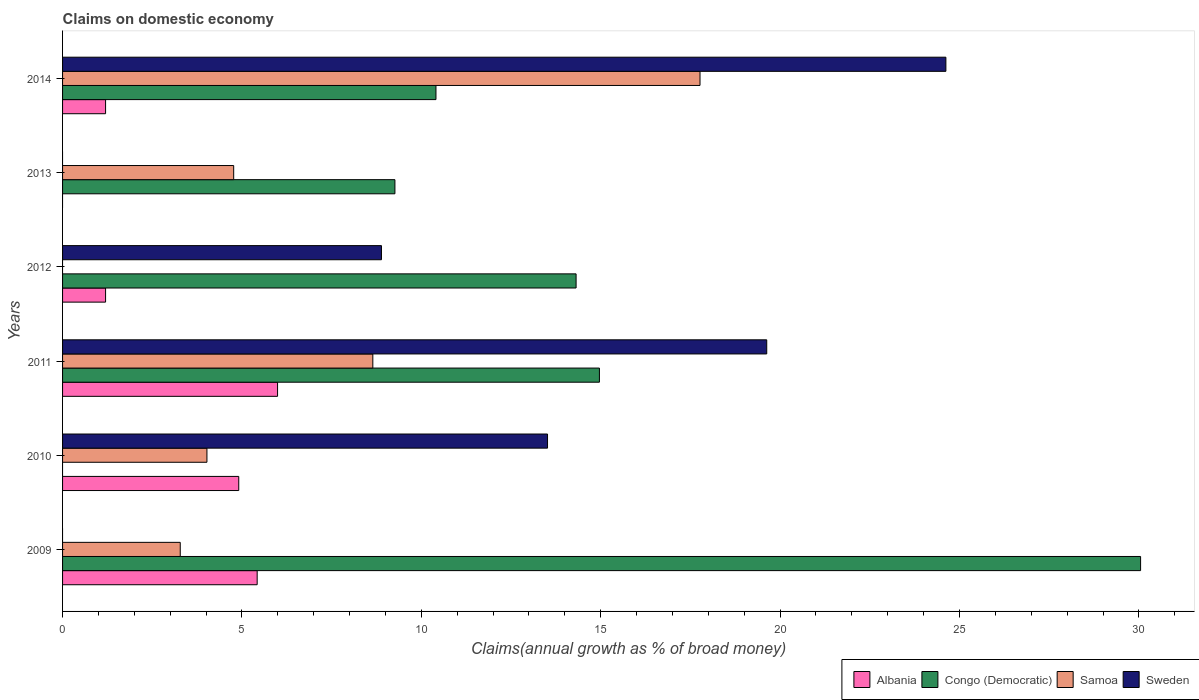How many different coloured bars are there?
Ensure brevity in your answer.  4. Are the number of bars on each tick of the Y-axis equal?
Provide a succinct answer. No. How many bars are there on the 3rd tick from the top?
Your response must be concise. 3. How many bars are there on the 3rd tick from the bottom?
Your response must be concise. 4. In how many cases, is the number of bars for a given year not equal to the number of legend labels?
Give a very brief answer. 4. What is the percentage of broad money claimed on domestic economy in Congo (Democratic) in 2010?
Your answer should be very brief. 0. Across all years, what is the maximum percentage of broad money claimed on domestic economy in Congo (Democratic)?
Your response must be concise. 30.05. Across all years, what is the minimum percentage of broad money claimed on domestic economy in Albania?
Your answer should be compact. 0. In which year was the percentage of broad money claimed on domestic economy in Sweden maximum?
Your answer should be very brief. 2014. What is the total percentage of broad money claimed on domestic economy in Congo (Democratic) in the graph?
Offer a very short reply. 79. What is the difference between the percentage of broad money claimed on domestic economy in Congo (Democratic) in 2009 and that in 2011?
Keep it short and to the point. 15.08. What is the difference between the percentage of broad money claimed on domestic economy in Sweden in 2010 and the percentage of broad money claimed on domestic economy in Albania in 2014?
Offer a terse response. 12.32. What is the average percentage of broad money claimed on domestic economy in Albania per year?
Offer a very short reply. 3.12. In the year 2014, what is the difference between the percentage of broad money claimed on domestic economy in Samoa and percentage of broad money claimed on domestic economy in Albania?
Your response must be concise. 16.57. In how many years, is the percentage of broad money claimed on domestic economy in Congo (Democratic) greater than 12 %?
Provide a succinct answer. 3. What is the ratio of the percentage of broad money claimed on domestic economy in Congo (Democratic) in 2009 to that in 2012?
Provide a succinct answer. 2.1. What is the difference between the highest and the second highest percentage of broad money claimed on domestic economy in Congo (Democratic)?
Provide a succinct answer. 15.08. What is the difference between the highest and the lowest percentage of broad money claimed on domestic economy in Albania?
Your response must be concise. 5.99. In how many years, is the percentage of broad money claimed on domestic economy in Albania greater than the average percentage of broad money claimed on domestic economy in Albania taken over all years?
Give a very brief answer. 3. Is it the case that in every year, the sum of the percentage of broad money claimed on domestic economy in Albania and percentage of broad money claimed on domestic economy in Samoa is greater than the sum of percentage of broad money claimed on domestic economy in Sweden and percentage of broad money claimed on domestic economy in Congo (Democratic)?
Give a very brief answer. No. Is it the case that in every year, the sum of the percentage of broad money claimed on domestic economy in Congo (Democratic) and percentage of broad money claimed on domestic economy in Albania is greater than the percentage of broad money claimed on domestic economy in Sweden?
Your response must be concise. No. Are all the bars in the graph horizontal?
Provide a short and direct response. Yes. How many years are there in the graph?
Offer a very short reply. 6. Does the graph contain grids?
Your answer should be very brief. No. How many legend labels are there?
Keep it short and to the point. 4. How are the legend labels stacked?
Your answer should be compact. Horizontal. What is the title of the graph?
Your response must be concise. Claims on domestic economy. What is the label or title of the X-axis?
Offer a terse response. Claims(annual growth as % of broad money). What is the label or title of the Y-axis?
Your response must be concise. Years. What is the Claims(annual growth as % of broad money) of Albania in 2009?
Provide a short and direct response. 5.42. What is the Claims(annual growth as % of broad money) in Congo (Democratic) in 2009?
Your answer should be compact. 30.05. What is the Claims(annual growth as % of broad money) of Samoa in 2009?
Keep it short and to the point. 3.28. What is the Claims(annual growth as % of broad money) of Sweden in 2009?
Make the answer very short. 0. What is the Claims(annual growth as % of broad money) of Albania in 2010?
Give a very brief answer. 4.91. What is the Claims(annual growth as % of broad money) of Congo (Democratic) in 2010?
Offer a terse response. 0. What is the Claims(annual growth as % of broad money) of Samoa in 2010?
Provide a short and direct response. 4.02. What is the Claims(annual growth as % of broad money) of Sweden in 2010?
Your answer should be compact. 13.52. What is the Claims(annual growth as % of broad money) of Albania in 2011?
Give a very brief answer. 5.99. What is the Claims(annual growth as % of broad money) of Congo (Democratic) in 2011?
Offer a very short reply. 14.96. What is the Claims(annual growth as % of broad money) in Samoa in 2011?
Provide a short and direct response. 8.65. What is the Claims(annual growth as % of broad money) in Sweden in 2011?
Keep it short and to the point. 19.63. What is the Claims(annual growth as % of broad money) in Albania in 2012?
Give a very brief answer. 1.2. What is the Claims(annual growth as % of broad money) of Congo (Democratic) in 2012?
Your response must be concise. 14.31. What is the Claims(annual growth as % of broad money) in Samoa in 2012?
Offer a terse response. 0. What is the Claims(annual growth as % of broad money) in Sweden in 2012?
Keep it short and to the point. 8.89. What is the Claims(annual growth as % of broad money) of Congo (Democratic) in 2013?
Provide a short and direct response. 9.26. What is the Claims(annual growth as % of broad money) of Samoa in 2013?
Your response must be concise. 4.77. What is the Claims(annual growth as % of broad money) of Sweden in 2013?
Your answer should be very brief. 0. What is the Claims(annual growth as % of broad money) in Albania in 2014?
Give a very brief answer. 1.2. What is the Claims(annual growth as % of broad money) of Congo (Democratic) in 2014?
Provide a succinct answer. 10.41. What is the Claims(annual growth as % of broad money) in Samoa in 2014?
Provide a short and direct response. 17.77. What is the Claims(annual growth as % of broad money) of Sweden in 2014?
Provide a succinct answer. 24.62. Across all years, what is the maximum Claims(annual growth as % of broad money) of Albania?
Give a very brief answer. 5.99. Across all years, what is the maximum Claims(annual growth as % of broad money) of Congo (Democratic)?
Ensure brevity in your answer.  30.05. Across all years, what is the maximum Claims(annual growth as % of broad money) in Samoa?
Your response must be concise. 17.77. Across all years, what is the maximum Claims(annual growth as % of broad money) in Sweden?
Your answer should be very brief. 24.62. Across all years, what is the minimum Claims(annual growth as % of broad money) in Congo (Democratic)?
Provide a short and direct response. 0. Across all years, what is the minimum Claims(annual growth as % of broad money) in Samoa?
Your answer should be compact. 0. Across all years, what is the minimum Claims(annual growth as % of broad money) of Sweden?
Ensure brevity in your answer.  0. What is the total Claims(annual growth as % of broad money) in Albania in the graph?
Provide a succinct answer. 18.73. What is the total Claims(annual growth as % of broad money) of Congo (Democratic) in the graph?
Offer a very short reply. 79. What is the total Claims(annual growth as % of broad money) in Samoa in the graph?
Make the answer very short. 38.49. What is the total Claims(annual growth as % of broad money) of Sweden in the graph?
Your answer should be compact. 66.65. What is the difference between the Claims(annual growth as % of broad money) in Albania in 2009 and that in 2010?
Make the answer very short. 0.51. What is the difference between the Claims(annual growth as % of broad money) of Samoa in 2009 and that in 2010?
Your response must be concise. -0.74. What is the difference between the Claims(annual growth as % of broad money) of Albania in 2009 and that in 2011?
Ensure brevity in your answer.  -0.57. What is the difference between the Claims(annual growth as % of broad money) of Congo (Democratic) in 2009 and that in 2011?
Keep it short and to the point. 15.08. What is the difference between the Claims(annual growth as % of broad money) of Samoa in 2009 and that in 2011?
Your answer should be compact. -5.37. What is the difference between the Claims(annual growth as % of broad money) in Albania in 2009 and that in 2012?
Your response must be concise. 4.23. What is the difference between the Claims(annual growth as % of broad money) in Congo (Democratic) in 2009 and that in 2012?
Keep it short and to the point. 15.73. What is the difference between the Claims(annual growth as % of broad money) in Congo (Democratic) in 2009 and that in 2013?
Offer a very short reply. 20.78. What is the difference between the Claims(annual growth as % of broad money) in Samoa in 2009 and that in 2013?
Provide a succinct answer. -1.49. What is the difference between the Claims(annual growth as % of broad money) of Albania in 2009 and that in 2014?
Your answer should be very brief. 4.23. What is the difference between the Claims(annual growth as % of broad money) in Congo (Democratic) in 2009 and that in 2014?
Your answer should be compact. 19.64. What is the difference between the Claims(annual growth as % of broad money) in Samoa in 2009 and that in 2014?
Your answer should be compact. -14.49. What is the difference between the Claims(annual growth as % of broad money) of Albania in 2010 and that in 2011?
Your response must be concise. -1.08. What is the difference between the Claims(annual growth as % of broad money) in Samoa in 2010 and that in 2011?
Provide a short and direct response. -4.62. What is the difference between the Claims(annual growth as % of broad money) of Sweden in 2010 and that in 2011?
Ensure brevity in your answer.  -6.11. What is the difference between the Claims(annual growth as % of broad money) in Albania in 2010 and that in 2012?
Provide a succinct answer. 3.71. What is the difference between the Claims(annual growth as % of broad money) of Sweden in 2010 and that in 2012?
Provide a short and direct response. 4.63. What is the difference between the Claims(annual growth as % of broad money) of Samoa in 2010 and that in 2013?
Keep it short and to the point. -0.75. What is the difference between the Claims(annual growth as % of broad money) in Albania in 2010 and that in 2014?
Your response must be concise. 3.71. What is the difference between the Claims(annual growth as % of broad money) of Samoa in 2010 and that in 2014?
Offer a terse response. -13.74. What is the difference between the Claims(annual growth as % of broad money) of Sweden in 2010 and that in 2014?
Give a very brief answer. -11.1. What is the difference between the Claims(annual growth as % of broad money) in Albania in 2011 and that in 2012?
Offer a very short reply. 4.79. What is the difference between the Claims(annual growth as % of broad money) of Congo (Democratic) in 2011 and that in 2012?
Make the answer very short. 0.65. What is the difference between the Claims(annual growth as % of broad money) in Sweden in 2011 and that in 2012?
Give a very brief answer. 10.74. What is the difference between the Claims(annual growth as % of broad money) in Congo (Democratic) in 2011 and that in 2013?
Provide a short and direct response. 5.7. What is the difference between the Claims(annual growth as % of broad money) in Samoa in 2011 and that in 2013?
Ensure brevity in your answer.  3.88. What is the difference between the Claims(annual growth as % of broad money) in Albania in 2011 and that in 2014?
Provide a succinct answer. 4.79. What is the difference between the Claims(annual growth as % of broad money) of Congo (Democratic) in 2011 and that in 2014?
Your response must be concise. 4.56. What is the difference between the Claims(annual growth as % of broad money) in Samoa in 2011 and that in 2014?
Your answer should be very brief. -9.12. What is the difference between the Claims(annual growth as % of broad money) in Sweden in 2011 and that in 2014?
Give a very brief answer. -4.99. What is the difference between the Claims(annual growth as % of broad money) in Congo (Democratic) in 2012 and that in 2013?
Keep it short and to the point. 5.05. What is the difference between the Claims(annual growth as % of broad money) of Albania in 2012 and that in 2014?
Give a very brief answer. -0. What is the difference between the Claims(annual growth as % of broad money) of Congo (Democratic) in 2012 and that in 2014?
Offer a terse response. 3.91. What is the difference between the Claims(annual growth as % of broad money) of Sweden in 2012 and that in 2014?
Make the answer very short. -15.73. What is the difference between the Claims(annual growth as % of broad money) of Congo (Democratic) in 2013 and that in 2014?
Your answer should be compact. -1.14. What is the difference between the Claims(annual growth as % of broad money) of Samoa in 2013 and that in 2014?
Keep it short and to the point. -13. What is the difference between the Claims(annual growth as % of broad money) of Albania in 2009 and the Claims(annual growth as % of broad money) of Samoa in 2010?
Offer a very short reply. 1.4. What is the difference between the Claims(annual growth as % of broad money) of Albania in 2009 and the Claims(annual growth as % of broad money) of Sweden in 2010?
Provide a short and direct response. -8.09. What is the difference between the Claims(annual growth as % of broad money) in Congo (Democratic) in 2009 and the Claims(annual growth as % of broad money) in Samoa in 2010?
Offer a terse response. 26.02. What is the difference between the Claims(annual growth as % of broad money) of Congo (Democratic) in 2009 and the Claims(annual growth as % of broad money) of Sweden in 2010?
Offer a terse response. 16.53. What is the difference between the Claims(annual growth as % of broad money) in Samoa in 2009 and the Claims(annual growth as % of broad money) in Sweden in 2010?
Your response must be concise. -10.24. What is the difference between the Claims(annual growth as % of broad money) in Albania in 2009 and the Claims(annual growth as % of broad money) in Congo (Democratic) in 2011?
Keep it short and to the point. -9.54. What is the difference between the Claims(annual growth as % of broad money) of Albania in 2009 and the Claims(annual growth as % of broad money) of Samoa in 2011?
Give a very brief answer. -3.22. What is the difference between the Claims(annual growth as % of broad money) of Albania in 2009 and the Claims(annual growth as % of broad money) of Sweden in 2011?
Your answer should be compact. -14.2. What is the difference between the Claims(annual growth as % of broad money) of Congo (Democratic) in 2009 and the Claims(annual growth as % of broad money) of Samoa in 2011?
Provide a succinct answer. 21.4. What is the difference between the Claims(annual growth as % of broad money) in Congo (Democratic) in 2009 and the Claims(annual growth as % of broad money) in Sweden in 2011?
Keep it short and to the point. 10.42. What is the difference between the Claims(annual growth as % of broad money) in Samoa in 2009 and the Claims(annual growth as % of broad money) in Sweden in 2011?
Provide a succinct answer. -16.35. What is the difference between the Claims(annual growth as % of broad money) in Albania in 2009 and the Claims(annual growth as % of broad money) in Congo (Democratic) in 2012?
Give a very brief answer. -8.89. What is the difference between the Claims(annual growth as % of broad money) in Albania in 2009 and the Claims(annual growth as % of broad money) in Sweden in 2012?
Keep it short and to the point. -3.46. What is the difference between the Claims(annual growth as % of broad money) in Congo (Democratic) in 2009 and the Claims(annual growth as % of broad money) in Sweden in 2012?
Provide a short and direct response. 21.16. What is the difference between the Claims(annual growth as % of broad money) in Samoa in 2009 and the Claims(annual growth as % of broad money) in Sweden in 2012?
Offer a terse response. -5.61. What is the difference between the Claims(annual growth as % of broad money) in Albania in 2009 and the Claims(annual growth as % of broad money) in Congo (Democratic) in 2013?
Keep it short and to the point. -3.84. What is the difference between the Claims(annual growth as % of broad money) of Albania in 2009 and the Claims(annual growth as % of broad money) of Samoa in 2013?
Your answer should be very brief. 0.65. What is the difference between the Claims(annual growth as % of broad money) in Congo (Democratic) in 2009 and the Claims(annual growth as % of broad money) in Samoa in 2013?
Offer a terse response. 25.28. What is the difference between the Claims(annual growth as % of broad money) of Albania in 2009 and the Claims(annual growth as % of broad money) of Congo (Democratic) in 2014?
Your answer should be compact. -4.98. What is the difference between the Claims(annual growth as % of broad money) of Albania in 2009 and the Claims(annual growth as % of broad money) of Samoa in 2014?
Ensure brevity in your answer.  -12.34. What is the difference between the Claims(annual growth as % of broad money) of Albania in 2009 and the Claims(annual growth as % of broad money) of Sweden in 2014?
Your answer should be compact. -19.2. What is the difference between the Claims(annual growth as % of broad money) in Congo (Democratic) in 2009 and the Claims(annual growth as % of broad money) in Samoa in 2014?
Your response must be concise. 12.28. What is the difference between the Claims(annual growth as % of broad money) of Congo (Democratic) in 2009 and the Claims(annual growth as % of broad money) of Sweden in 2014?
Make the answer very short. 5.43. What is the difference between the Claims(annual growth as % of broad money) of Samoa in 2009 and the Claims(annual growth as % of broad money) of Sweden in 2014?
Your answer should be very brief. -21.34. What is the difference between the Claims(annual growth as % of broad money) of Albania in 2010 and the Claims(annual growth as % of broad money) of Congo (Democratic) in 2011?
Make the answer very short. -10.05. What is the difference between the Claims(annual growth as % of broad money) of Albania in 2010 and the Claims(annual growth as % of broad money) of Samoa in 2011?
Provide a short and direct response. -3.74. What is the difference between the Claims(annual growth as % of broad money) of Albania in 2010 and the Claims(annual growth as % of broad money) of Sweden in 2011?
Your answer should be compact. -14.72. What is the difference between the Claims(annual growth as % of broad money) in Samoa in 2010 and the Claims(annual growth as % of broad money) in Sweden in 2011?
Ensure brevity in your answer.  -15.6. What is the difference between the Claims(annual growth as % of broad money) in Albania in 2010 and the Claims(annual growth as % of broad money) in Congo (Democratic) in 2012?
Provide a short and direct response. -9.4. What is the difference between the Claims(annual growth as % of broad money) of Albania in 2010 and the Claims(annual growth as % of broad money) of Sweden in 2012?
Your response must be concise. -3.98. What is the difference between the Claims(annual growth as % of broad money) in Samoa in 2010 and the Claims(annual growth as % of broad money) in Sweden in 2012?
Keep it short and to the point. -4.86. What is the difference between the Claims(annual growth as % of broad money) in Albania in 2010 and the Claims(annual growth as % of broad money) in Congo (Democratic) in 2013?
Keep it short and to the point. -4.35. What is the difference between the Claims(annual growth as % of broad money) of Albania in 2010 and the Claims(annual growth as % of broad money) of Samoa in 2013?
Provide a short and direct response. 0.14. What is the difference between the Claims(annual growth as % of broad money) in Albania in 2010 and the Claims(annual growth as % of broad money) in Congo (Democratic) in 2014?
Offer a very short reply. -5.5. What is the difference between the Claims(annual growth as % of broad money) of Albania in 2010 and the Claims(annual growth as % of broad money) of Samoa in 2014?
Offer a terse response. -12.86. What is the difference between the Claims(annual growth as % of broad money) of Albania in 2010 and the Claims(annual growth as % of broad money) of Sweden in 2014?
Ensure brevity in your answer.  -19.71. What is the difference between the Claims(annual growth as % of broad money) in Samoa in 2010 and the Claims(annual growth as % of broad money) in Sweden in 2014?
Offer a very short reply. -20.6. What is the difference between the Claims(annual growth as % of broad money) of Albania in 2011 and the Claims(annual growth as % of broad money) of Congo (Democratic) in 2012?
Give a very brief answer. -8.32. What is the difference between the Claims(annual growth as % of broad money) in Albania in 2011 and the Claims(annual growth as % of broad money) in Sweden in 2012?
Your answer should be very brief. -2.9. What is the difference between the Claims(annual growth as % of broad money) in Congo (Democratic) in 2011 and the Claims(annual growth as % of broad money) in Sweden in 2012?
Keep it short and to the point. 6.08. What is the difference between the Claims(annual growth as % of broad money) in Samoa in 2011 and the Claims(annual growth as % of broad money) in Sweden in 2012?
Provide a short and direct response. -0.24. What is the difference between the Claims(annual growth as % of broad money) in Albania in 2011 and the Claims(annual growth as % of broad money) in Congo (Democratic) in 2013?
Your response must be concise. -3.27. What is the difference between the Claims(annual growth as % of broad money) in Albania in 2011 and the Claims(annual growth as % of broad money) in Samoa in 2013?
Provide a succinct answer. 1.22. What is the difference between the Claims(annual growth as % of broad money) of Congo (Democratic) in 2011 and the Claims(annual growth as % of broad money) of Samoa in 2013?
Provide a succinct answer. 10.19. What is the difference between the Claims(annual growth as % of broad money) of Albania in 2011 and the Claims(annual growth as % of broad money) of Congo (Democratic) in 2014?
Offer a very short reply. -4.42. What is the difference between the Claims(annual growth as % of broad money) in Albania in 2011 and the Claims(annual growth as % of broad money) in Samoa in 2014?
Your answer should be compact. -11.78. What is the difference between the Claims(annual growth as % of broad money) of Albania in 2011 and the Claims(annual growth as % of broad money) of Sweden in 2014?
Give a very brief answer. -18.63. What is the difference between the Claims(annual growth as % of broad money) of Congo (Democratic) in 2011 and the Claims(annual growth as % of broad money) of Samoa in 2014?
Your response must be concise. -2.8. What is the difference between the Claims(annual growth as % of broad money) of Congo (Democratic) in 2011 and the Claims(annual growth as % of broad money) of Sweden in 2014?
Make the answer very short. -9.66. What is the difference between the Claims(annual growth as % of broad money) of Samoa in 2011 and the Claims(annual growth as % of broad money) of Sweden in 2014?
Offer a very short reply. -15.97. What is the difference between the Claims(annual growth as % of broad money) in Albania in 2012 and the Claims(annual growth as % of broad money) in Congo (Democratic) in 2013?
Your answer should be very brief. -8.07. What is the difference between the Claims(annual growth as % of broad money) in Albania in 2012 and the Claims(annual growth as % of broad money) in Samoa in 2013?
Ensure brevity in your answer.  -3.57. What is the difference between the Claims(annual growth as % of broad money) of Congo (Democratic) in 2012 and the Claims(annual growth as % of broad money) of Samoa in 2013?
Your response must be concise. 9.54. What is the difference between the Claims(annual growth as % of broad money) of Albania in 2012 and the Claims(annual growth as % of broad money) of Congo (Democratic) in 2014?
Keep it short and to the point. -9.21. What is the difference between the Claims(annual growth as % of broad money) in Albania in 2012 and the Claims(annual growth as % of broad money) in Samoa in 2014?
Your answer should be compact. -16.57. What is the difference between the Claims(annual growth as % of broad money) in Albania in 2012 and the Claims(annual growth as % of broad money) in Sweden in 2014?
Offer a terse response. -23.42. What is the difference between the Claims(annual growth as % of broad money) in Congo (Democratic) in 2012 and the Claims(annual growth as % of broad money) in Samoa in 2014?
Provide a short and direct response. -3.45. What is the difference between the Claims(annual growth as % of broad money) of Congo (Democratic) in 2012 and the Claims(annual growth as % of broad money) of Sweden in 2014?
Provide a short and direct response. -10.31. What is the difference between the Claims(annual growth as % of broad money) of Congo (Democratic) in 2013 and the Claims(annual growth as % of broad money) of Samoa in 2014?
Keep it short and to the point. -8.5. What is the difference between the Claims(annual growth as % of broad money) of Congo (Democratic) in 2013 and the Claims(annual growth as % of broad money) of Sweden in 2014?
Ensure brevity in your answer.  -15.36. What is the difference between the Claims(annual growth as % of broad money) in Samoa in 2013 and the Claims(annual growth as % of broad money) in Sweden in 2014?
Give a very brief answer. -19.85. What is the average Claims(annual growth as % of broad money) in Albania per year?
Offer a very short reply. 3.12. What is the average Claims(annual growth as % of broad money) of Congo (Democratic) per year?
Your answer should be very brief. 13.17. What is the average Claims(annual growth as % of broad money) of Samoa per year?
Keep it short and to the point. 6.42. What is the average Claims(annual growth as % of broad money) in Sweden per year?
Your answer should be compact. 11.11. In the year 2009, what is the difference between the Claims(annual growth as % of broad money) of Albania and Claims(annual growth as % of broad money) of Congo (Democratic)?
Ensure brevity in your answer.  -24.62. In the year 2009, what is the difference between the Claims(annual growth as % of broad money) of Albania and Claims(annual growth as % of broad money) of Samoa?
Your answer should be very brief. 2.14. In the year 2009, what is the difference between the Claims(annual growth as % of broad money) of Congo (Democratic) and Claims(annual growth as % of broad money) of Samoa?
Give a very brief answer. 26.77. In the year 2010, what is the difference between the Claims(annual growth as % of broad money) in Albania and Claims(annual growth as % of broad money) in Samoa?
Your response must be concise. 0.89. In the year 2010, what is the difference between the Claims(annual growth as % of broad money) of Albania and Claims(annual growth as % of broad money) of Sweden?
Your answer should be compact. -8.61. In the year 2010, what is the difference between the Claims(annual growth as % of broad money) in Samoa and Claims(annual growth as % of broad money) in Sweden?
Offer a terse response. -9.49. In the year 2011, what is the difference between the Claims(annual growth as % of broad money) in Albania and Claims(annual growth as % of broad money) in Congo (Democratic)?
Your answer should be very brief. -8.97. In the year 2011, what is the difference between the Claims(annual growth as % of broad money) in Albania and Claims(annual growth as % of broad money) in Samoa?
Your answer should be very brief. -2.66. In the year 2011, what is the difference between the Claims(annual growth as % of broad money) in Albania and Claims(annual growth as % of broad money) in Sweden?
Ensure brevity in your answer.  -13.63. In the year 2011, what is the difference between the Claims(annual growth as % of broad money) of Congo (Democratic) and Claims(annual growth as % of broad money) of Samoa?
Offer a terse response. 6.32. In the year 2011, what is the difference between the Claims(annual growth as % of broad money) in Congo (Democratic) and Claims(annual growth as % of broad money) in Sweden?
Give a very brief answer. -4.66. In the year 2011, what is the difference between the Claims(annual growth as % of broad money) in Samoa and Claims(annual growth as % of broad money) in Sweden?
Provide a short and direct response. -10.98. In the year 2012, what is the difference between the Claims(annual growth as % of broad money) in Albania and Claims(annual growth as % of broad money) in Congo (Democratic)?
Your answer should be very brief. -13.11. In the year 2012, what is the difference between the Claims(annual growth as % of broad money) in Albania and Claims(annual growth as % of broad money) in Sweden?
Offer a very short reply. -7.69. In the year 2012, what is the difference between the Claims(annual growth as % of broad money) in Congo (Democratic) and Claims(annual growth as % of broad money) in Sweden?
Offer a terse response. 5.42. In the year 2013, what is the difference between the Claims(annual growth as % of broad money) in Congo (Democratic) and Claims(annual growth as % of broad money) in Samoa?
Offer a very short reply. 4.49. In the year 2014, what is the difference between the Claims(annual growth as % of broad money) in Albania and Claims(annual growth as % of broad money) in Congo (Democratic)?
Ensure brevity in your answer.  -9.21. In the year 2014, what is the difference between the Claims(annual growth as % of broad money) in Albania and Claims(annual growth as % of broad money) in Samoa?
Your response must be concise. -16.57. In the year 2014, what is the difference between the Claims(annual growth as % of broad money) in Albania and Claims(annual growth as % of broad money) in Sweden?
Make the answer very short. -23.42. In the year 2014, what is the difference between the Claims(annual growth as % of broad money) of Congo (Democratic) and Claims(annual growth as % of broad money) of Samoa?
Give a very brief answer. -7.36. In the year 2014, what is the difference between the Claims(annual growth as % of broad money) of Congo (Democratic) and Claims(annual growth as % of broad money) of Sweden?
Offer a terse response. -14.21. In the year 2014, what is the difference between the Claims(annual growth as % of broad money) of Samoa and Claims(annual growth as % of broad money) of Sweden?
Offer a very short reply. -6.85. What is the ratio of the Claims(annual growth as % of broad money) in Albania in 2009 to that in 2010?
Give a very brief answer. 1.1. What is the ratio of the Claims(annual growth as % of broad money) of Samoa in 2009 to that in 2010?
Provide a short and direct response. 0.82. What is the ratio of the Claims(annual growth as % of broad money) in Albania in 2009 to that in 2011?
Your answer should be very brief. 0.91. What is the ratio of the Claims(annual growth as % of broad money) of Congo (Democratic) in 2009 to that in 2011?
Give a very brief answer. 2.01. What is the ratio of the Claims(annual growth as % of broad money) in Samoa in 2009 to that in 2011?
Your response must be concise. 0.38. What is the ratio of the Claims(annual growth as % of broad money) in Albania in 2009 to that in 2012?
Give a very brief answer. 4.52. What is the ratio of the Claims(annual growth as % of broad money) in Congo (Democratic) in 2009 to that in 2012?
Make the answer very short. 2.1. What is the ratio of the Claims(annual growth as % of broad money) of Congo (Democratic) in 2009 to that in 2013?
Offer a terse response. 3.24. What is the ratio of the Claims(annual growth as % of broad money) in Samoa in 2009 to that in 2013?
Provide a short and direct response. 0.69. What is the ratio of the Claims(annual growth as % of broad money) in Albania in 2009 to that in 2014?
Offer a very short reply. 4.52. What is the ratio of the Claims(annual growth as % of broad money) in Congo (Democratic) in 2009 to that in 2014?
Ensure brevity in your answer.  2.89. What is the ratio of the Claims(annual growth as % of broad money) in Samoa in 2009 to that in 2014?
Your response must be concise. 0.18. What is the ratio of the Claims(annual growth as % of broad money) of Albania in 2010 to that in 2011?
Your response must be concise. 0.82. What is the ratio of the Claims(annual growth as % of broad money) of Samoa in 2010 to that in 2011?
Make the answer very short. 0.47. What is the ratio of the Claims(annual growth as % of broad money) in Sweden in 2010 to that in 2011?
Make the answer very short. 0.69. What is the ratio of the Claims(annual growth as % of broad money) in Albania in 2010 to that in 2012?
Provide a succinct answer. 4.1. What is the ratio of the Claims(annual growth as % of broad money) in Sweden in 2010 to that in 2012?
Provide a short and direct response. 1.52. What is the ratio of the Claims(annual growth as % of broad money) of Samoa in 2010 to that in 2013?
Offer a very short reply. 0.84. What is the ratio of the Claims(annual growth as % of broad money) in Albania in 2010 to that in 2014?
Make the answer very short. 4.1. What is the ratio of the Claims(annual growth as % of broad money) in Samoa in 2010 to that in 2014?
Your answer should be very brief. 0.23. What is the ratio of the Claims(annual growth as % of broad money) in Sweden in 2010 to that in 2014?
Make the answer very short. 0.55. What is the ratio of the Claims(annual growth as % of broad money) of Albania in 2011 to that in 2012?
Provide a succinct answer. 5. What is the ratio of the Claims(annual growth as % of broad money) in Congo (Democratic) in 2011 to that in 2012?
Your response must be concise. 1.05. What is the ratio of the Claims(annual growth as % of broad money) of Sweden in 2011 to that in 2012?
Offer a very short reply. 2.21. What is the ratio of the Claims(annual growth as % of broad money) of Congo (Democratic) in 2011 to that in 2013?
Provide a short and direct response. 1.62. What is the ratio of the Claims(annual growth as % of broad money) in Samoa in 2011 to that in 2013?
Give a very brief answer. 1.81. What is the ratio of the Claims(annual growth as % of broad money) in Albania in 2011 to that in 2014?
Your answer should be compact. 5. What is the ratio of the Claims(annual growth as % of broad money) of Congo (Democratic) in 2011 to that in 2014?
Keep it short and to the point. 1.44. What is the ratio of the Claims(annual growth as % of broad money) of Samoa in 2011 to that in 2014?
Your answer should be very brief. 0.49. What is the ratio of the Claims(annual growth as % of broad money) in Sweden in 2011 to that in 2014?
Ensure brevity in your answer.  0.8. What is the ratio of the Claims(annual growth as % of broad money) in Congo (Democratic) in 2012 to that in 2013?
Give a very brief answer. 1.55. What is the ratio of the Claims(annual growth as % of broad money) of Albania in 2012 to that in 2014?
Your answer should be compact. 1. What is the ratio of the Claims(annual growth as % of broad money) of Congo (Democratic) in 2012 to that in 2014?
Give a very brief answer. 1.38. What is the ratio of the Claims(annual growth as % of broad money) of Sweden in 2012 to that in 2014?
Provide a short and direct response. 0.36. What is the ratio of the Claims(annual growth as % of broad money) of Congo (Democratic) in 2013 to that in 2014?
Provide a short and direct response. 0.89. What is the ratio of the Claims(annual growth as % of broad money) in Samoa in 2013 to that in 2014?
Make the answer very short. 0.27. What is the difference between the highest and the second highest Claims(annual growth as % of broad money) of Albania?
Offer a very short reply. 0.57. What is the difference between the highest and the second highest Claims(annual growth as % of broad money) of Congo (Democratic)?
Your answer should be very brief. 15.08. What is the difference between the highest and the second highest Claims(annual growth as % of broad money) of Samoa?
Your answer should be very brief. 9.12. What is the difference between the highest and the second highest Claims(annual growth as % of broad money) in Sweden?
Your answer should be very brief. 4.99. What is the difference between the highest and the lowest Claims(annual growth as % of broad money) in Albania?
Offer a very short reply. 5.99. What is the difference between the highest and the lowest Claims(annual growth as % of broad money) of Congo (Democratic)?
Provide a succinct answer. 30.05. What is the difference between the highest and the lowest Claims(annual growth as % of broad money) in Samoa?
Provide a succinct answer. 17.77. What is the difference between the highest and the lowest Claims(annual growth as % of broad money) of Sweden?
Provide a short and direct response. 24.62. 